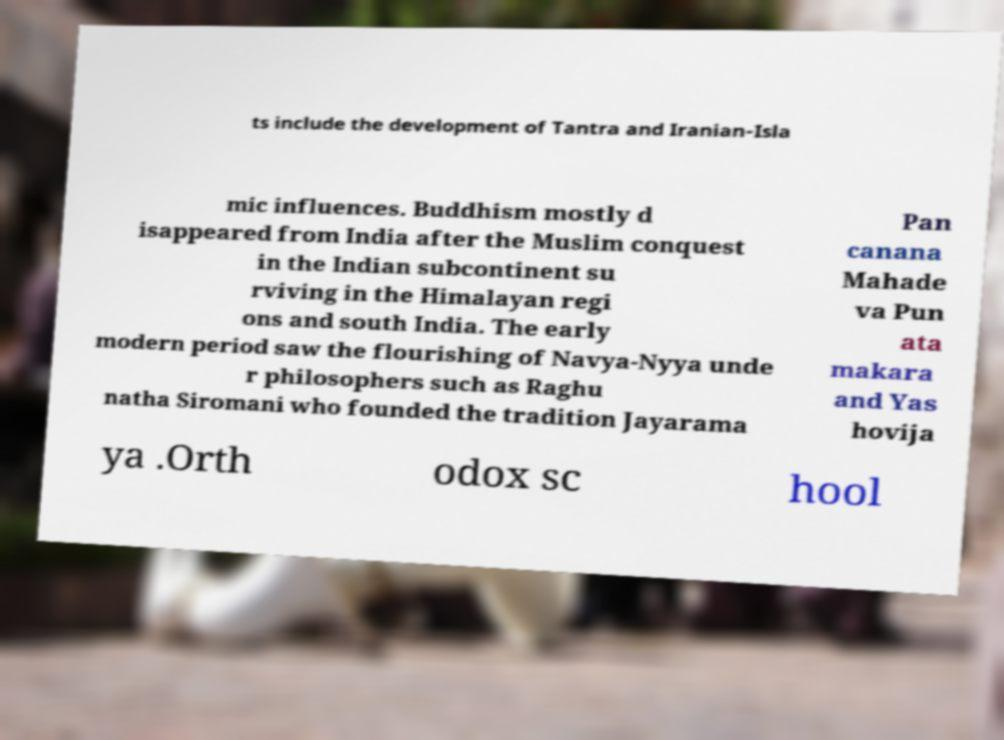What messages or text are displayed in this image? I need them in a readable, typed format. ts include the development of Tantra and Iranian-Isla mic influences. Buddhism mostly d isappeared from India after the Muslim conquest in the Indian subcontinent su rviving in the Himalayan regi ons and south India. The early modern period saw the flourishing of Navya-Nyya unde r philosophers such as Raghu natha Siromani who founded the tradition Jayarama Pan canana Mahade va Pun ata makara and Yas hovija ya .Orth odox sc hool 